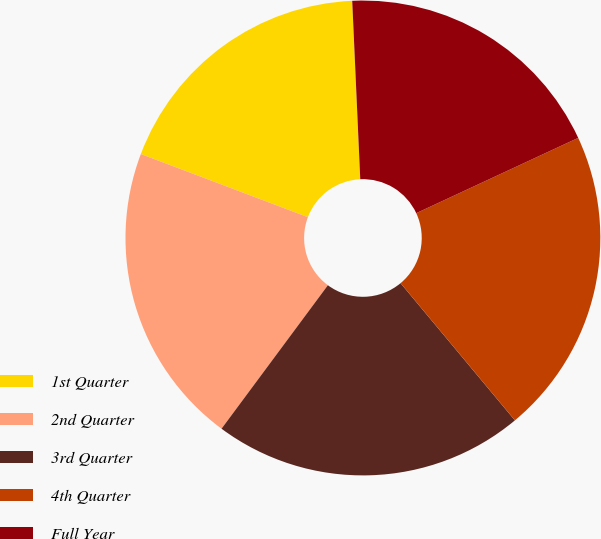Convert chart to OTSL. <chart><loc_0><loc_0><loc_500><loc_500><pie_chart><fcel>1st Quarter<fcel>2nd Quarter<fcel>3rd Quarter<fcel>4th Quarter<fcel>Full Year<nl><fcel>18.53%<fcel>20.6%<fcel>21.21%<fcel>20.87%<fcel>18.79%<nl></chart> 